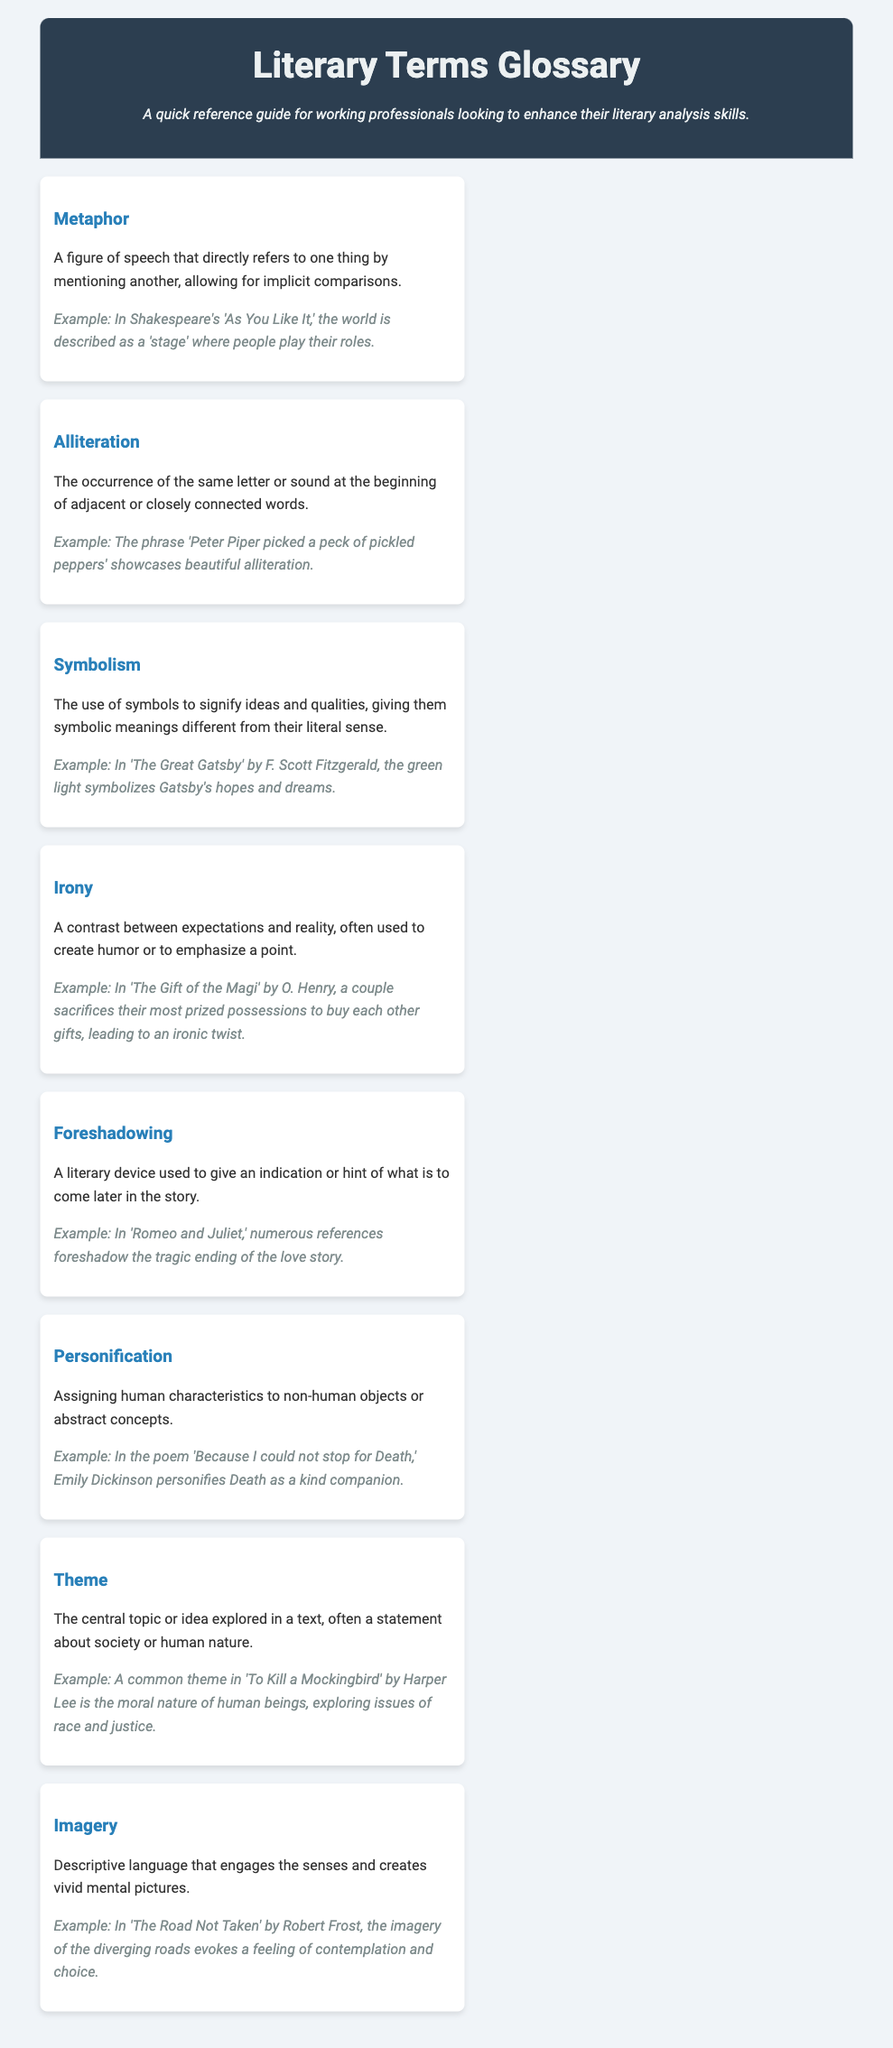What is the title of the document? The title is the main heading of the document that indicates its content.
Answer: Literary Terms Glossary What literary term is defined as assigning human characteristics to non-human objects? This term is described in the document, allowing for easy identification.
Answer: Personification Which literary term uses symbols to signify ideas and qualities? This question seeks to identify a specific term related to symbolism.
Answer: Symbolism In which literary work is the phrase "the world is described as a 'stage'" used? The document provides an example of this term from a well-known play.
Answer: As You Like It What common theme is explored in 'To Kill a Mockingbird'? This question looks for a significant idea mentioned in relation to a specific book.
Answer: Moral nature of human beings Find a term that describes the occurrence of the same letter at the beginning of closely connected words. The document explicitly defines this stylistic feature.
Answer: Alliteration What is the purpose of foreshadowing, according to the glossary? This question requires understanding of the term's function in literature as described in the document.
Answer: To give an indication or hint of what is to come later Which example illustrates symbolism in 'The Great Gatsby'? The question focuses on identifying a specific example provided in the text.
Answer: The green light symbolizes Gatsby's hopes and dreams What type of document is this? The term describes the nature of the document and its intent.
Answer: Glossary 